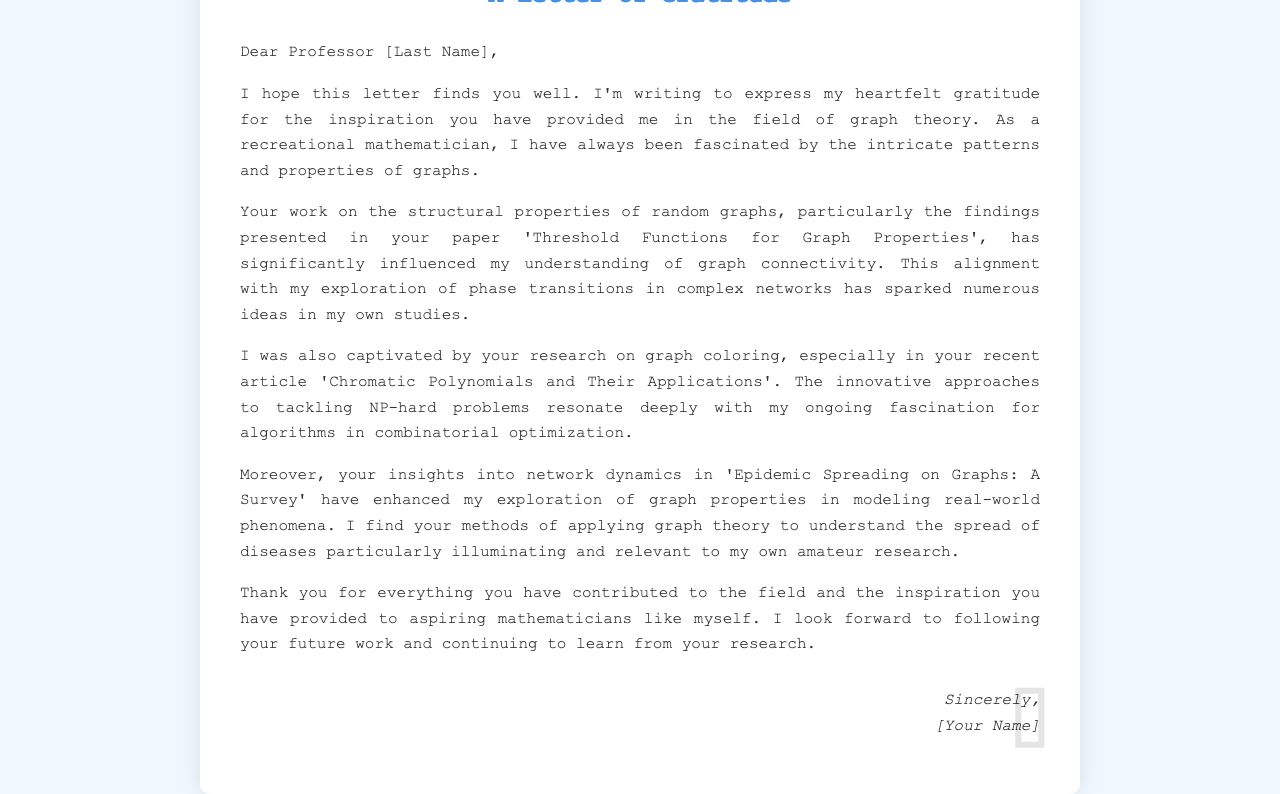What is the title of the letter? The title of the letter is introduced at the top of the document, clearly stated within an <h1> tag.
Answer: A Letter of Gratitude Who is the letter addressed to? The letter is personalized and directed to a specific individual, mentioned as Professor followed by their last name.
Answer: Professor [Last Name] What key area of research does the author express gratitude for? The author highlights the specific field that inspired them, which is indicated in their appreciation for the professor's contributions.
Answer: Graph theory Which paper by the professor is mentioned regarding random graphs? The specific paper referenced in the letter signifies a significant impact on the author's understanding of graph connectivity.
Answer: Threshold Functions for Graph Properties What topic is discussed in relation to graph coloring? The author mentions a specific aspect of the professor's research, indicating a focus on a challenging area in graph theory.
Answer: Chromatic Polynomials and Their Applications In which survey does the professor provide insights into epidemic spreading? The document references a survey that showcases the application of graph theory to a real-world scenario that caught the author's interest.
Answer: Epidemic Spreading on Graphs: A Survey What kind of mathematician identifies the author? The document presents a descriptor of the author's approach to mathematics that reflects their engagement with the subject.
Answer: Recreational mathematician What does the author look forward to following? The author expresses a desire to keep track of the professor's future contributions in the field, indicating an ongoing interest in learning.
Answer: Future work 